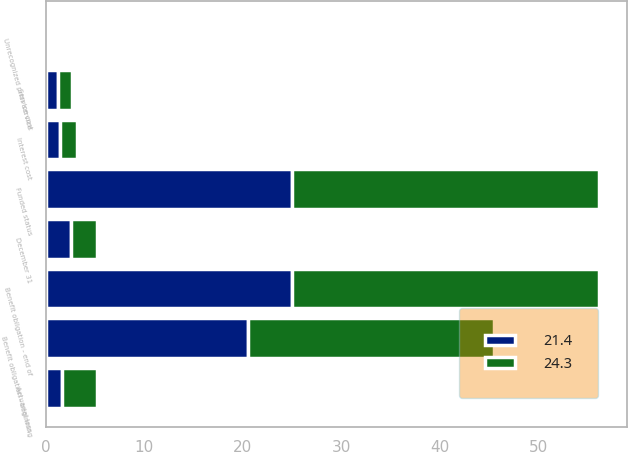Convert chart to OTSL. <chart><loc_0><loc_0><loc_500><loc_500><stacked_bar_chart><ecel><fcel>December 31<fcel>Benefit obligation - beginning<fcel>Service cost<fcel>Interest cost<fcel>Actuarial loss<fcel>Benefit obligation - end of<fcel>Funded status<fcel>Unrecognized prior service<nl><fcel>24.3<fcel>2.6<fcel>25<fcel>1.4<fcel>1.7<fcel>3.5<fcel>31.2<fcel>31.2<fcel>0.1<nl><fcel>21.4<fcel>2.6<fcel>20.5<fcel>1.3<fcel>1.5<fcel>1.7<fcel>25<fcel>25<fcel>0.1<nl></chart> 